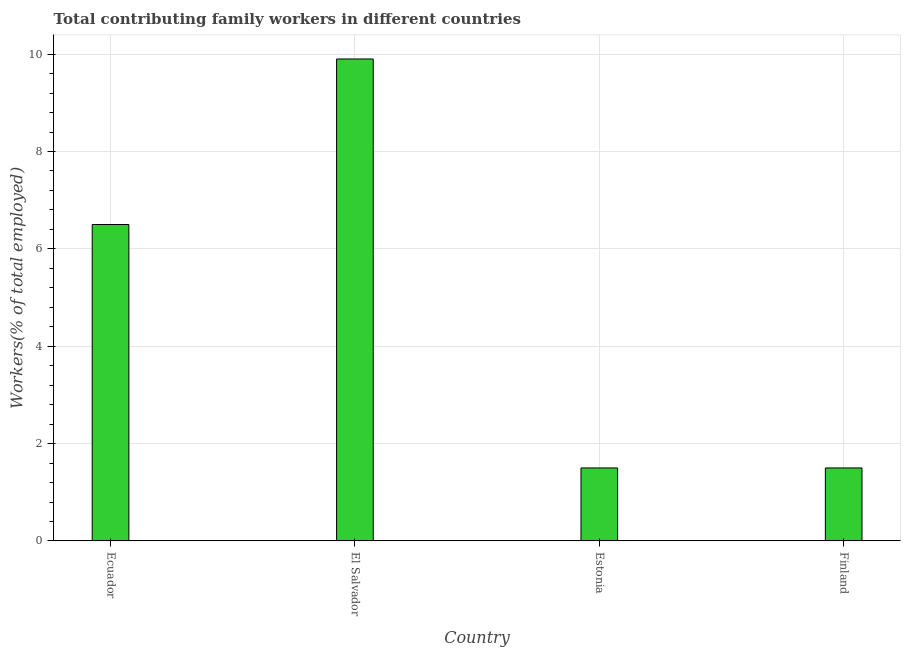Does the graph contain grids?
Offer a very short reply. Yes. What is the title of the graph?
Provide a short and direct response. Total contributing family workers in different countries. What is the label or title of the X-axis?
Your answer should be very brief. Country. What is the label or title of the Y-axis?
Offer a very short reply. Workers(% of total employed). What is the contributing family workers in Ecuador?
Make the answer very short. 6.5. Across all countries, what is the maximum contributing family workers?
Your answer should be very brief. 9.9. In which country was the contributing family workers maximum?
Ensure brevity in your answer.  El Salvador. In which country was the contributing family workers minimum?
Offer a terse response. Estonia. What is the sum of the contributing family workers?
Give a very brief answer. 19.4. What is the average contributing family workers per country?
Ensure brevity in your answer.  4.85. In how many countries, is the contributing family workers greater than 4.8 %?
Your response must be concise. 2. What is the ratio of the contributing family workers in El Salvador to that in Finland?
Ensure brevity in your answer.  6.6. Is the contributing family workers in Ecuador less than that in Finland?
Ensure brevity in your answer.  No. Is the difference between the contributing family workers in El Salvador and Finland greater than the difference between any two countries?
Offer a very short reply. Yes. What is the difference between the highest and the second highest contributing family workers?
Your response must be concise. 3.4. What is the difference between the highest and the lowest contributing family workers?
Give a very brief answer. 8.4. In how many countries, is the contributing family workers greater than the average contributing family workers taken over all countries?
Your answer should be very brief. 2. How many bars are there?
Provide a short and direct response. 4. Are the values on the major ticks of Y-axis written in scientific E-notation?
Keep it short and to the point. No. What is the Workers(% of total employed) of Ecuador?
Offer a very short reply. 6.5. What is the Workers(% of total employed) in El Salvador?
Provide a succinct answer. 9.9. What is the Workers(% of total employed) of Estonia?
Your answer should be compact. 1.5. What is the Workers(% of total employed) of Finland?
Offer a terse response. 1.5. What is the difference between the Workers(% of total employed) in Ecuador and El Salvador?
Give a very brief answer. -3.4. What is the difference between the Workers(% of total employed) in Ecuador and Estonia?
Keep it short and to the point. 5. What is the difference between the Workers(% of total employed) in El Salvador and Estonia?
Provide a short and direct response. 8.4. What is the difference between the Workers(% of total employed) in Estonia and Finland?
Keep it short and to the point. 0. What is the ratio of the Workers(% of total employed) in Ecuador to that in El Salvador?
Provide a short and direct response. 0.66. What is the ratio of the Workers(% of total employed) in Ecuador to that in Estonia?
Offer a very short reply. 4.33. What is the ratio of the Workers(% of total employed) in Ecuador to that in Finland?
Ensure brevity in your answer.  4.33. What is the ratio of the Workers(% of total employed) in El Salvador to that in Estonia?
Give a very brief answer. 6.6. What is the ratio of the Workers(% of total employed) in El Salvador to that in Finland?
Keep it short and to the point. 6.6. 